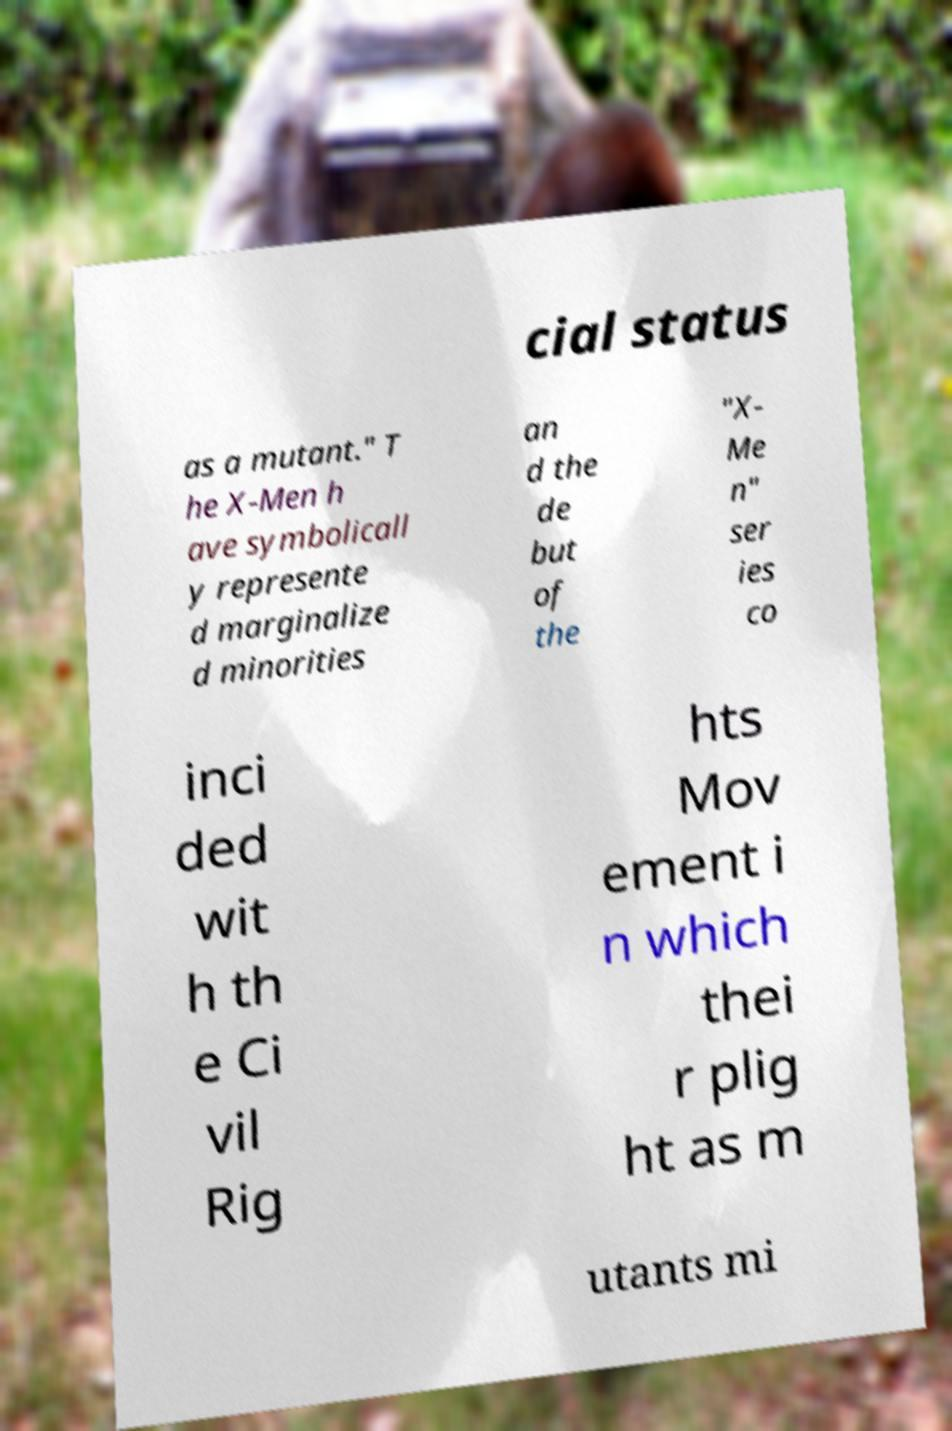For documentation purposes, I need the text within this image transcribed. Could you provide that? cial status as a mutant." T he X-Men h ave symbolicall y represente d marginalize d minorities an d the de but of the "X- Me n" ser ies co inci ded wit h th e Ci vil Rig hts Mov ement i n which thei r plig ht as m utants mi 